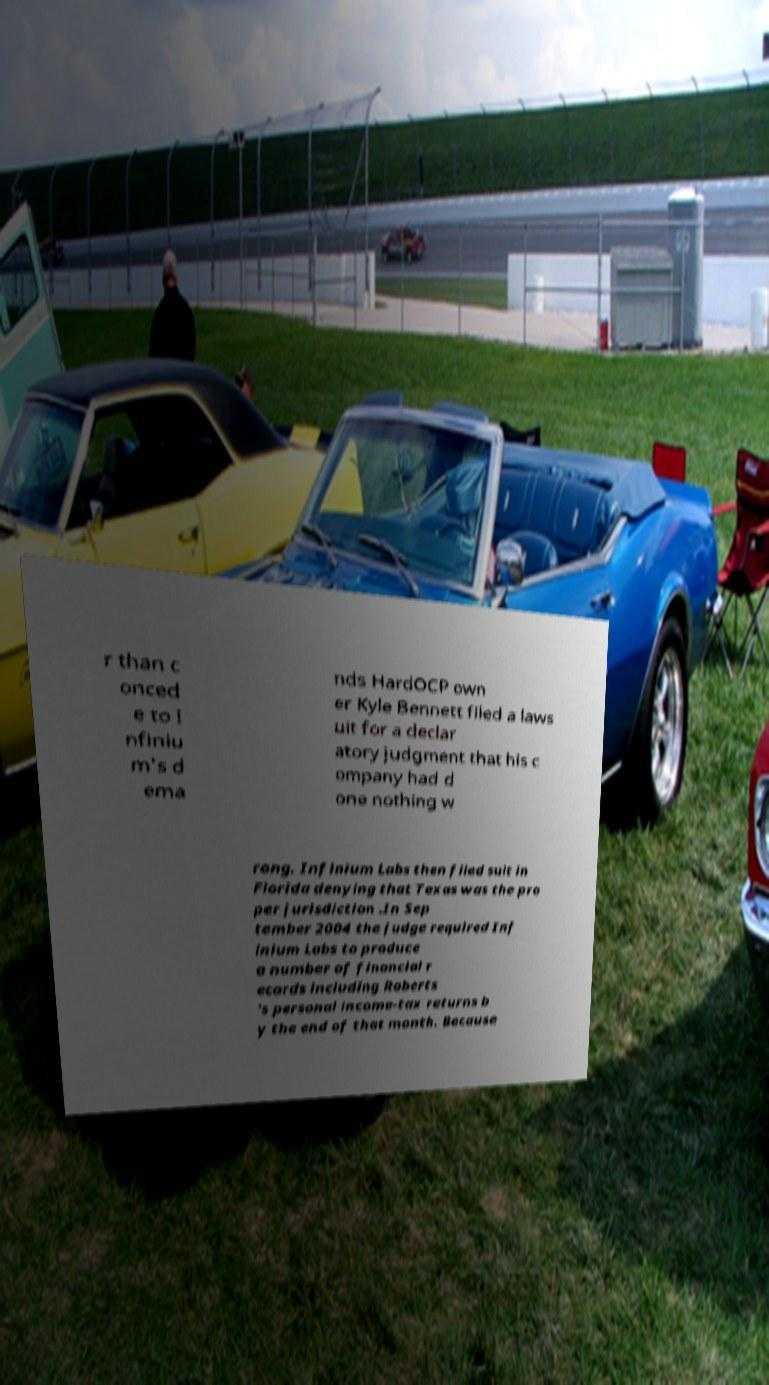Can you read and provide the text displayed in the image?This photo seems to have some interesting text. Can you extract and type it out for me? r than c onced e to I nfiniu m's d ema nds HardOCP own er Kyle Bennett filed a laws uit for a declar atory judgment that his c ompany had d one nothing w rong. Infinium Labs then filed suit in Florida denying that Texas was the pro per jurisdiction .In Sep tember 2004 the judge required Inf inium Labs to produce a number of financial r ecords including Roberts 's personal income-tax returns b y the end of that month. Because 